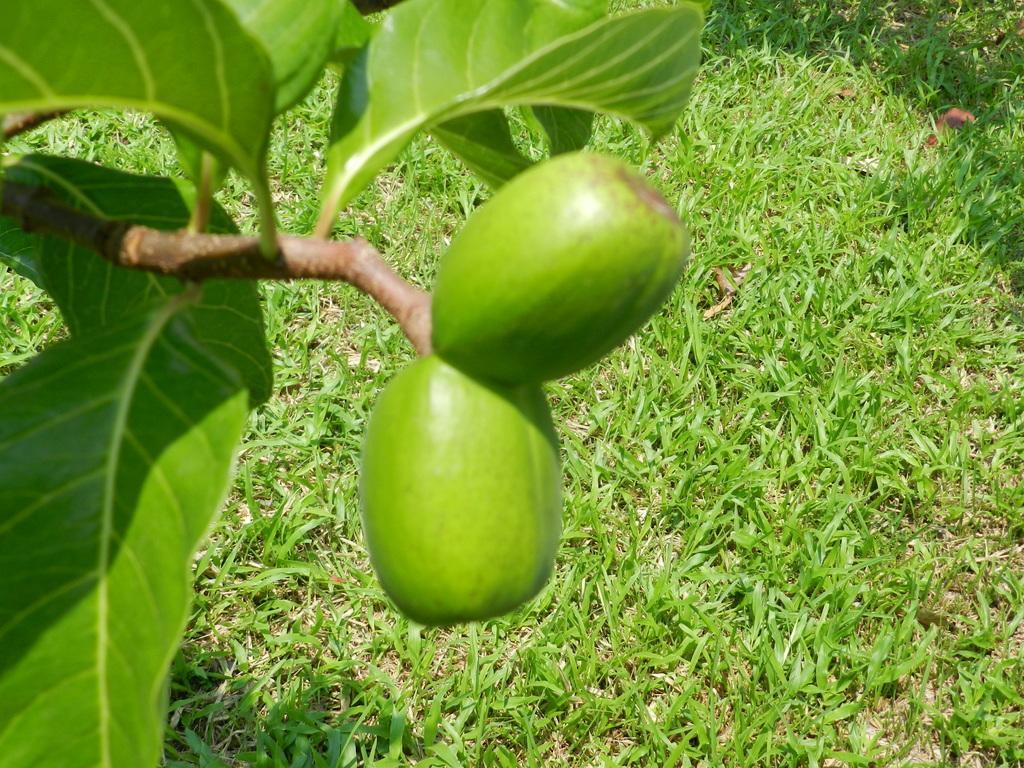Can you describe this image briefly? In this image, I can see two fruits hanging to the branch. I think this is the tree with branches, leaves and fruits. This is the grass. 